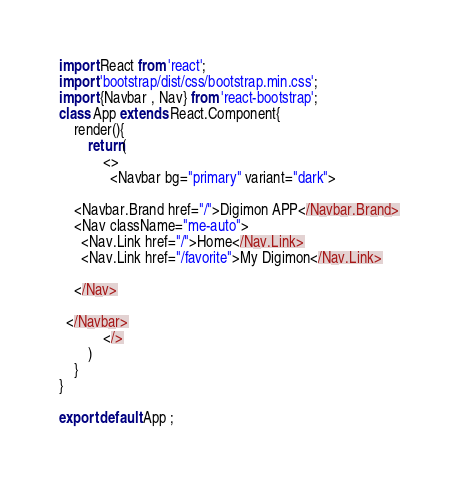<code> <loc_0><loc_0><loc_500><loc_500><_JavaScript_>import React from 'react';
import 'bootstrap/dist/css/bootstrap.min.css';
import {Navbar , Nav} from 'react-bootstrap';
class App extends React.Component{
    render(){
        return(
            <>
              <Navbar bg="primary" variant="dark">
    
    <Navbar.Brand href="/">Digimon APP</Navbar.Brand>
    <Nav className="me-auto">
      <Nav.Link href="/">Home</Nav.Link>
      <Nav.Link href="/favorite">My Digimon</Nav.Link>
      
    </Nav>

  </Navbar>
            </>
        )
    }
}

export default App ;</code> 